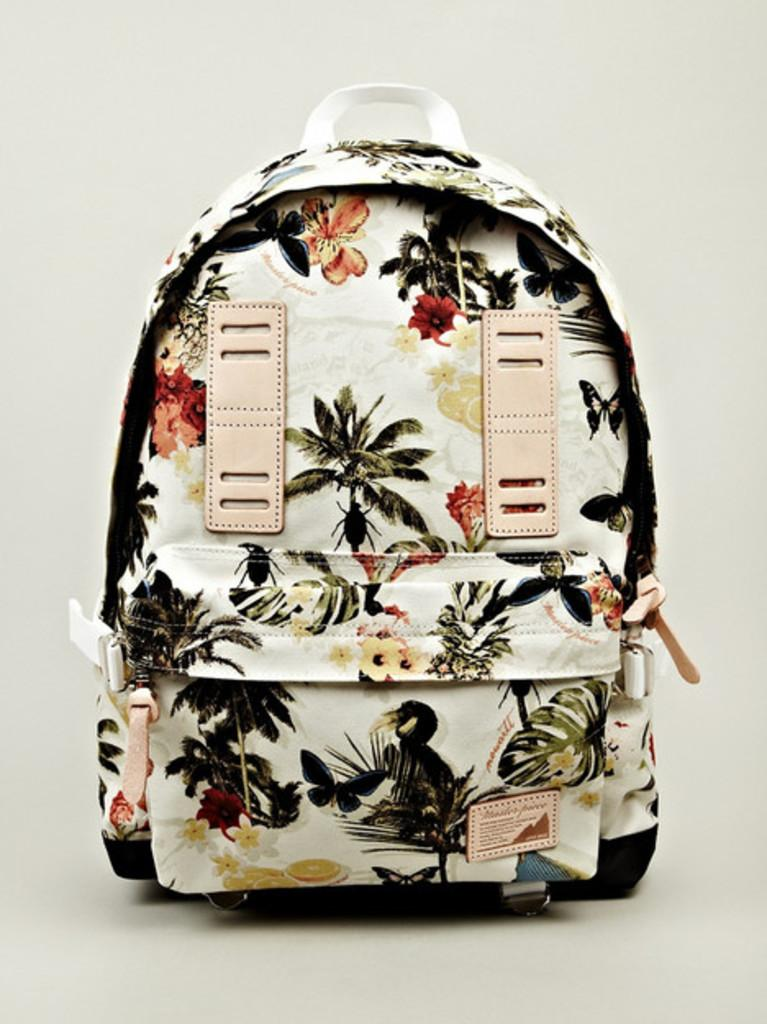What object is present in the image that can be used for carrying items? There is a bag in the image that can be used for carrying items. What can be observed about the appearance of the bag? The bag has designs on it. How can the bag be secured or closed? The bag has zip handles for securing or closing it. Where is the bag located in the image? The bag is placed on a table. What can be seen in the background of the image? There is a wall in the background of the image. What type of insurance is required for the bag in the image? There is no mention of insurance in the image. --- Facts: 1. There is a person in the image. 2. The person is wearing a hat. 3. The person is holding a book. 4. The book has a title on the cover. 5. The background of the image is a park. Absurd Topics: dinosaur, ocean, submarine Conversation: Who or what is present in the image? There is a person in the image. What can be observed about the person's attire? The person is wearing a hat. What is the person holding in the image? The person is holding a book. What can be seen on the book's cover? The book has a title on the cover. What can be seen in the background of the image? The background of the image is a park. Reasoning: Let's think step by step in order to produce the conversation. We start by identifying the main subject in the image, which is the person. Then, we describe specific details about the person, such as their attire and what they are holding. Next, we focus on the book, mentioning its title on the cover. Finally, we describe the background of the image, which is a park. Absurd Question/Answer: Can a dinosaur be seen swimming in the ocean in the image? There is no dinosaur or ocean present in the image. 